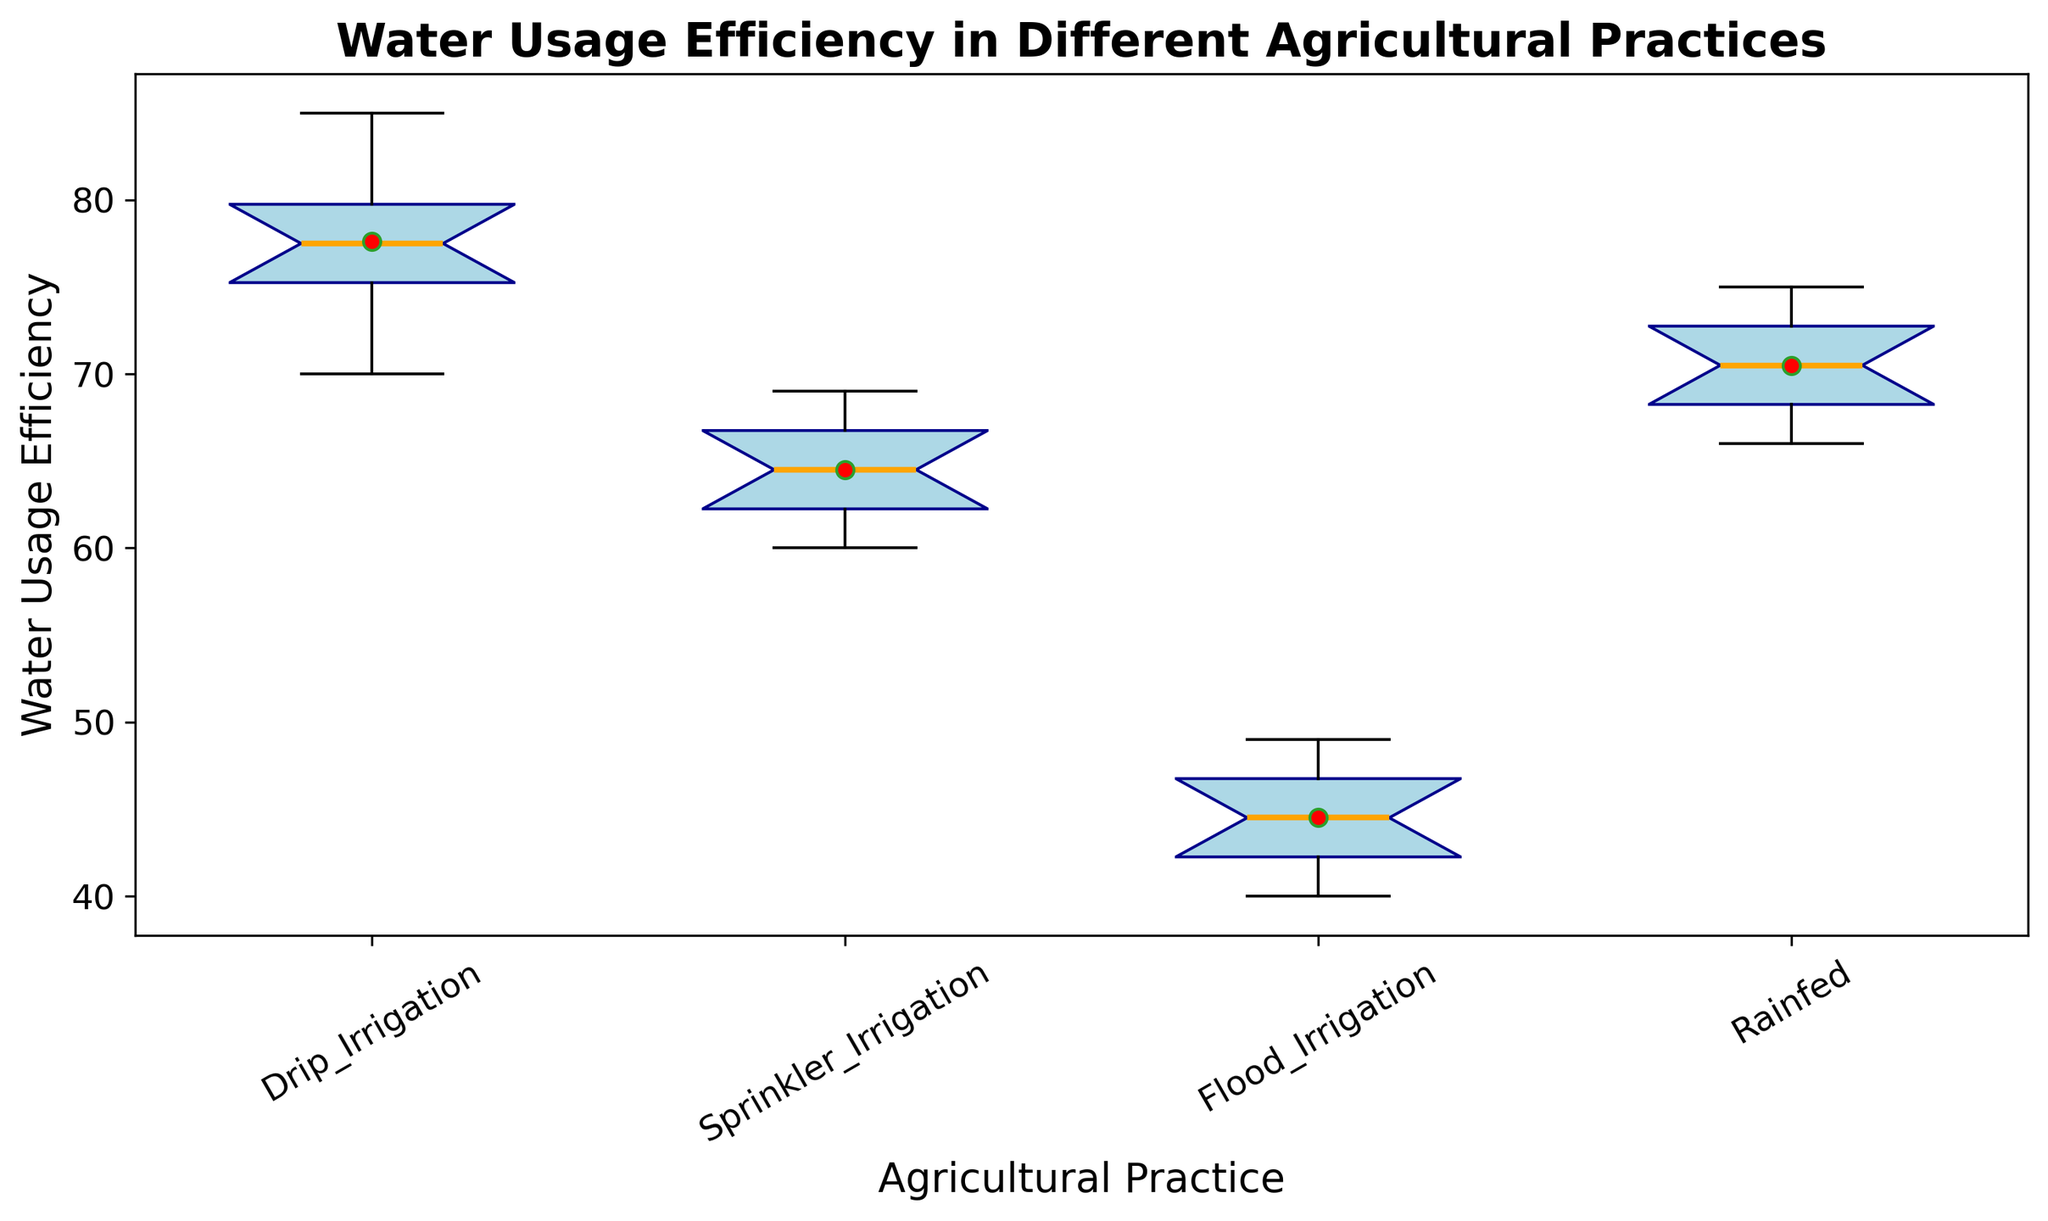What's the median Water Usage Efficiency for Drip Irrigation? The median is the middle value of the sorted data set. For Drip Irrigation, the sorted data set is [70, 74, 75, 76, 77, 78, 79, 80, 82, 85], and the median is (77 + 78) / 2 = 77.5
Answer: 77.5 Which agricultural practice has the highest mean Water Usage Efficiency? The mean Water Usage Efficiency is indicated by the red circle in each box plot. Drip Irrigation has the highest mean, as its red circle is at a higher value compared to the red circles of the other practices.
Answer: Drip Irrigation Which agricultural practice has the smallest range of Water Usage Efficiency? The range is the difference between the maximum and minimum values. By observing the length of each box plot, Rainfed has the smallest range because its whiskers are the shortest compared to other box plots.
Answer: Rainfed What is the difference between the upper quartile of Sprinkler Irrigation and the lower quartile of Flood Irrigation? The upper quartile (75th percentile) is at the top of the box and the lower quartile (25th percentile) is at the bottom of the box. For Sprinkler Irrigation, the upper quartile is 67. For Flood Irrigation, the lower quartile is 42. Therefore, the difference is 67 - 42 = 25.
Answer: 25 Which agricultural practice shows the widest interquartile range (IQR) for Water Usage Efficiency? The IQR is the range of the middle 50% of the data, represented by the height of the box. Flood Irrigation has the widest box, indicating it has the widest IQR.
Answer: Flood Irrigation In which agricultural practice does the median value differ the most from the mean value? The median is the line inside the box and the mean is the red circle. For Drip Irrigation, the median (77.5) is very close to its mean. Sprinkler Irrigation also shows a close position. For Flood Irrigation, there is a noticeable difference between the mean and median. Rainfed also shows a difference, but Flood Irrigation has a more significant difference.
Answer: Flood Irrigation Which agricultural practice has the highest minimum value of Water Usage Efficiency? The minimum value is represented by the lowest point in the whisker. Drip Irrigation has the highest minimum value as its lowest whisker point is above the others.
Answer: Drip Irrigation 